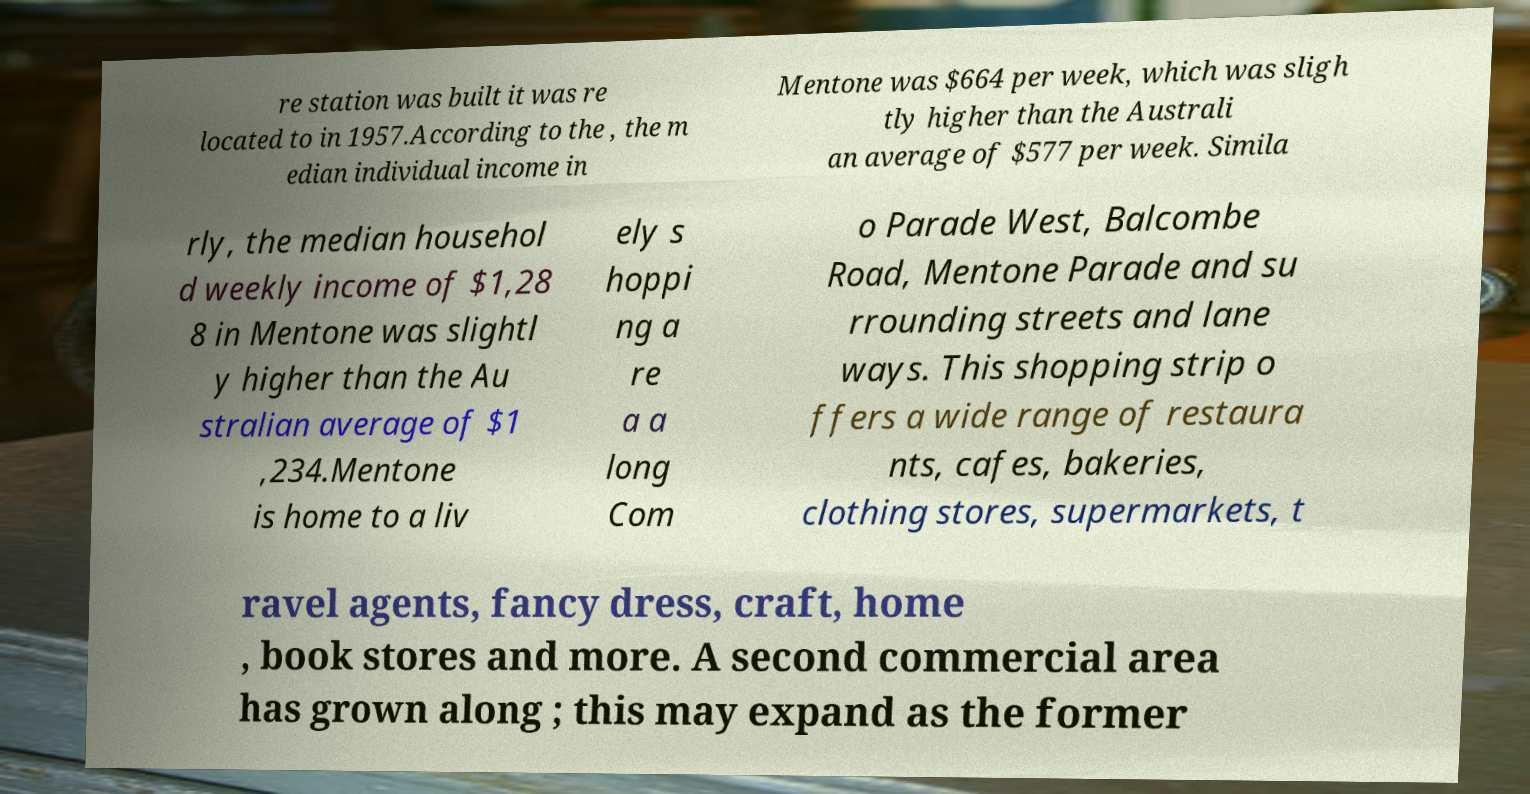Could you extract and type out the text from this image? re station was built it was re located to in 1957.According to the , the m edian individual income in Mentone was $664 per week, which was sligh tly higher than the Australi an average of $577 per week. Simila rly, the median househol d weekly income of $1,28 8 in Mentone was slightl y higher than the Au stralian average of $1 ,234.Mentone is home to a liv ely s hoppi ng a re a a long Com o Parade West, Balcombe Road, Mentone Parade and su rrounding streets and lane ways. This shopping strip o ffers a wide range of restaura nts, cafes, bakeries, clothing stores, supermarkets, t ravel agents, fancy dress, craft, home , book stores and more. A second commercial area has grown along ; this may expand as the former 